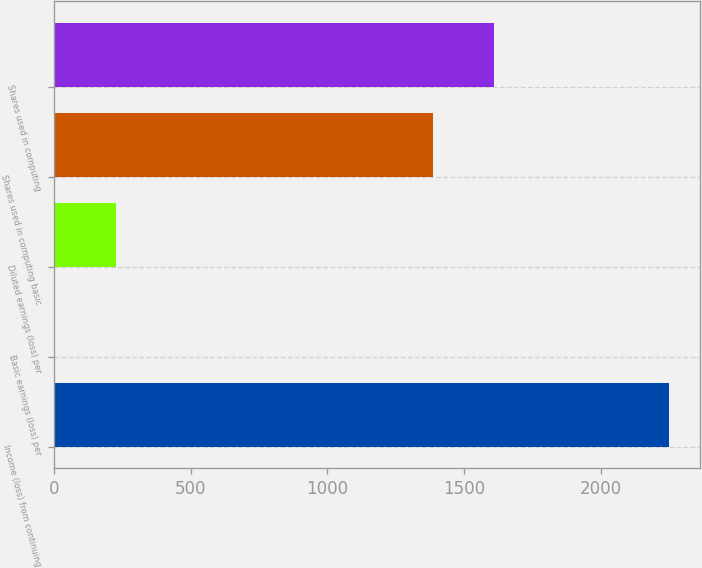Convert chart to OTSL. <chart><loc_0><loc_0><loc_500><loc_500><bar_chart><fcel>Income (loss) from continuing<fcel>Basic earnings (loss) per<fcel>Diluted earnings (loss) per<fcel>Shares used in computing basic<fcel>Shares used in computing<nl><fcel>2251<fcel>1.62<fcel>226.56<fcel>1386<fcel>1610.94<nl></chart> 